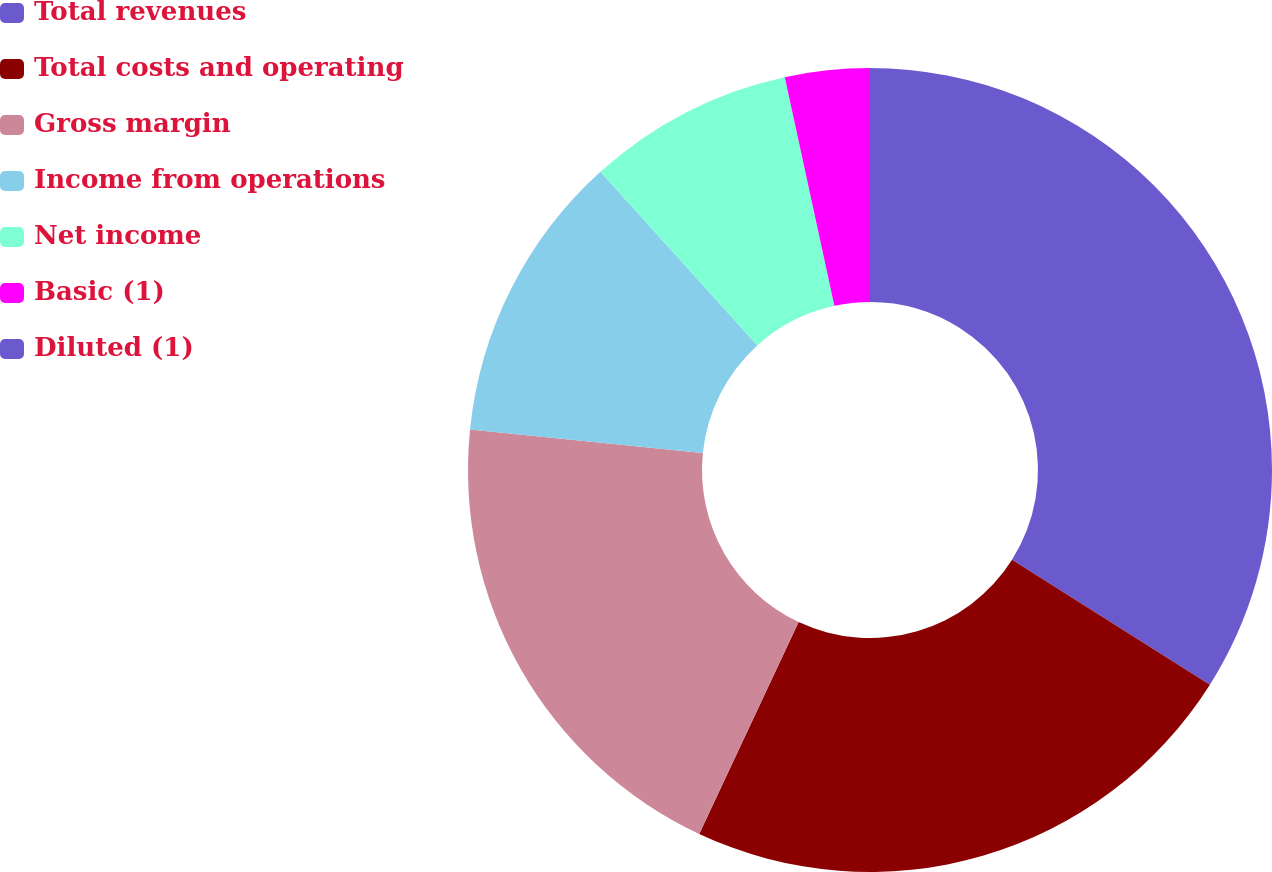Convert chart to OTSL. <chart><loc_0><loc_0><loc_500><loc_500><pie_chart><fcel>Total revenues<fcel>Total costs and operating<fcel>Gross margin<fcel>Income from operations<fcel>Net income<fcel>Basic (1)<fcel>Diluted (1)<nl><fcel>33.97%<fcel>23.02%<fcel>19.62%<fcel>11.7%<fcel>8.3%<fcel>3.4%<fcel>0.0%<nl></chart> 